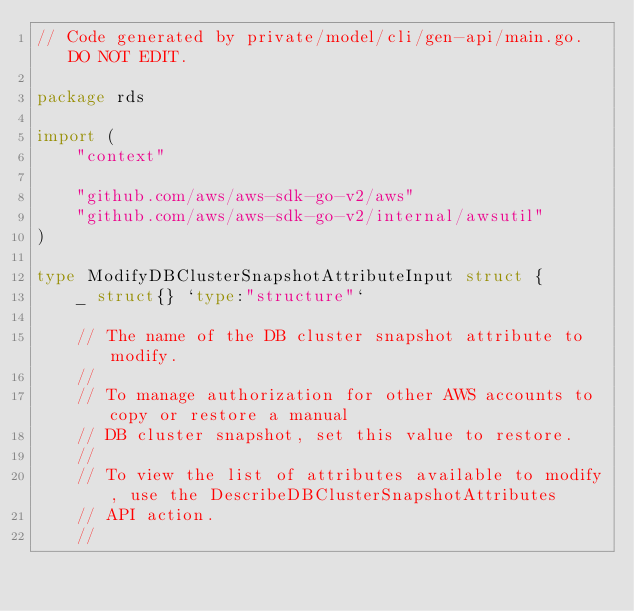Convert code to text. <code><loc_0><loc_0><loc_500><loc_500><_Go_>// Code generated by private/model/cli/gen-api/main.go. DO NOT EDIT.

package rds

import (
	"context"

	"github.com/aws/aws-sdk-go-v2/aws"
	"github.com/aws/aws-sdk-go-v2/internal/awsutil"
)

type ModifyDBClusterSnapshotAttributeInput struct {
	_ struct{} `type:"structure"`

	// The name of the DB cluster snapshot attribute to modify.
	//
	// To manage authorization for other AWS accounts to copy or restore a manual
	// DB cluster snapshot, set this value to restore.
	//
	// To view the list of attributes available to modify, use the DescribeDBClusterSnapshotAttributes
	// API action.
	//</code> 